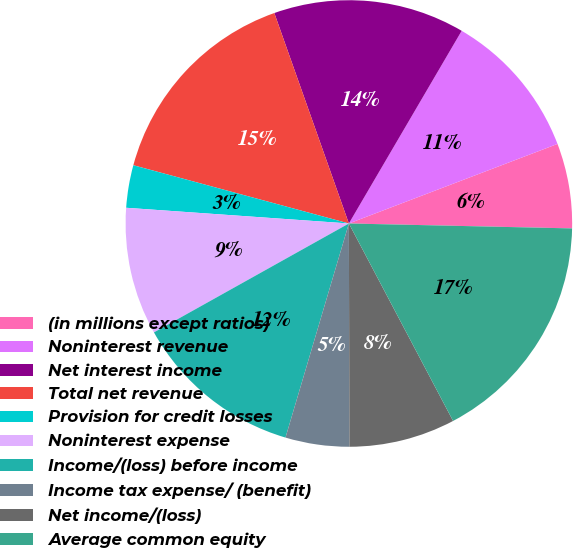<chart> <loc_0><loc_0><loc_500><loc_500><pie_chart><fcel>(in millions except ratios)<fcel>Noninterest revenue<fcel>Net interest income<fcel>Total net revenue<fcel>Provision for credit losses<fcel>Noninterest expense<fcel>Income/(loss) before income<fcel>Income tax expense/ (benefit)<fcel>Net income/(loss)<fcel>Average common equity<nl><fcel>6.15%<fcel>10.77%<fcel>13.85%<fcel>15.38%<fcel>3.08%<fcel>9.23%<fcel>12.31%<fcel>4.62%<fcel>7.69%<fcel>16.92%<nl></chart> 